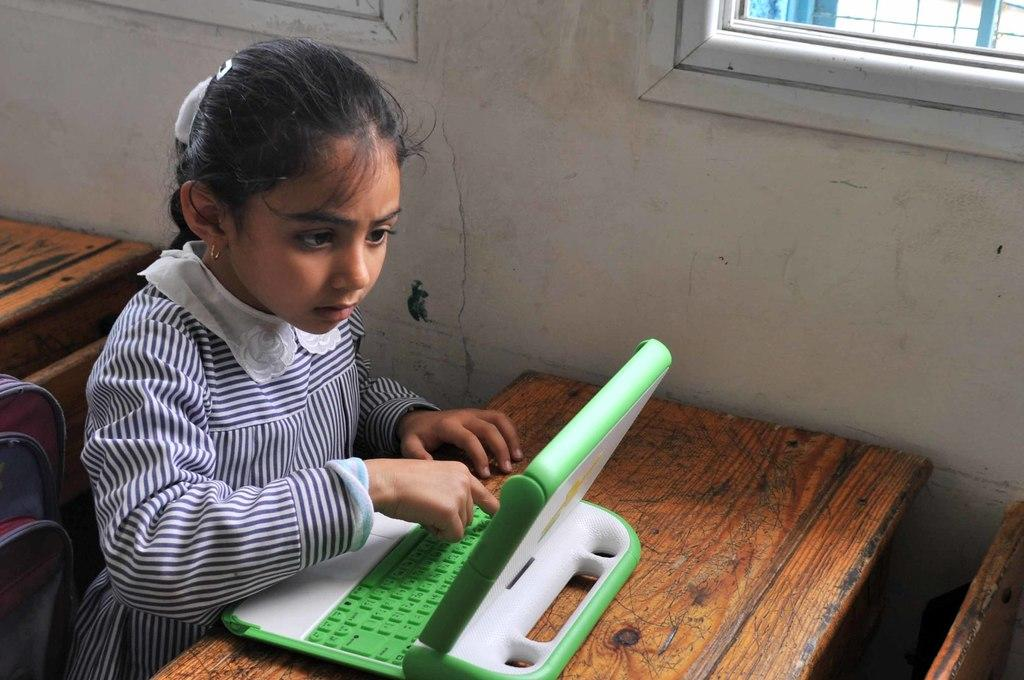Who is the main subject in the picture? There is a girl in the picture. What is the girl doing in the image? The girl is sitting on a bench and typing on a laptop. What other objects are present in the image? There is a table and a bag in the image. What type of vegetable is the girl holding in the image? There is no vegetable present in the image; the girl is typing on a laptop. 